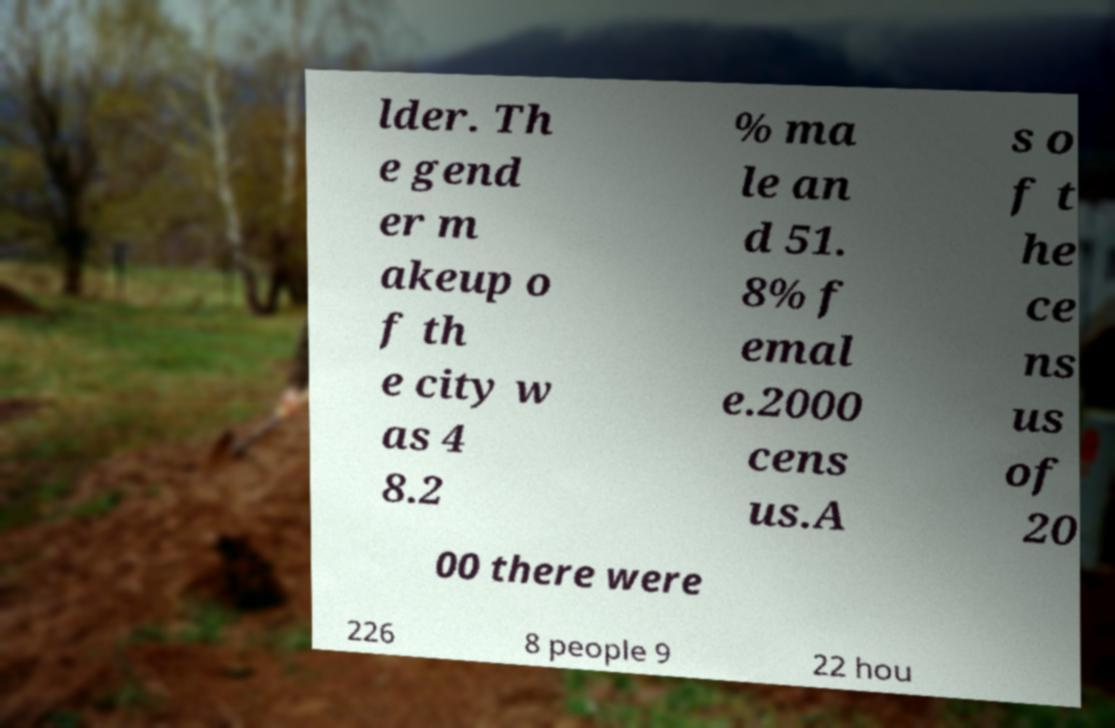Please read and relay the text visible in this image. What does it say? lder. Th e gend er m akeup o f th e city w as 4 8.2 % ma le an d 51. 8% f emal e.2000 cens us.A s o f t he ce ns us of 20 00 there were 226 8 people 9 22 hou 